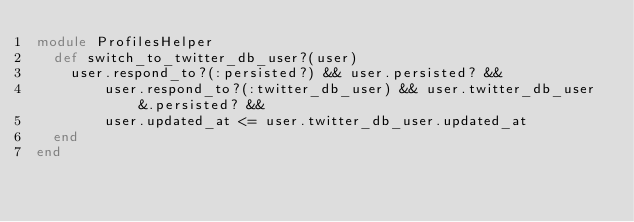<code> <loc_0><loc_0><loc_500><loc_500><_Ruby_>module ProfilesHelper
  def switch_to_twitter_db_user?(user)
    user.respond_to?(:persisted?) && user.persisted? &&
        user.respond_to?(:twitter_db_user) && user.twitter_db_user&.persisted? &&
        user.updated_at <= user.twitter_db_user.updated_at
  end
end
</code> 